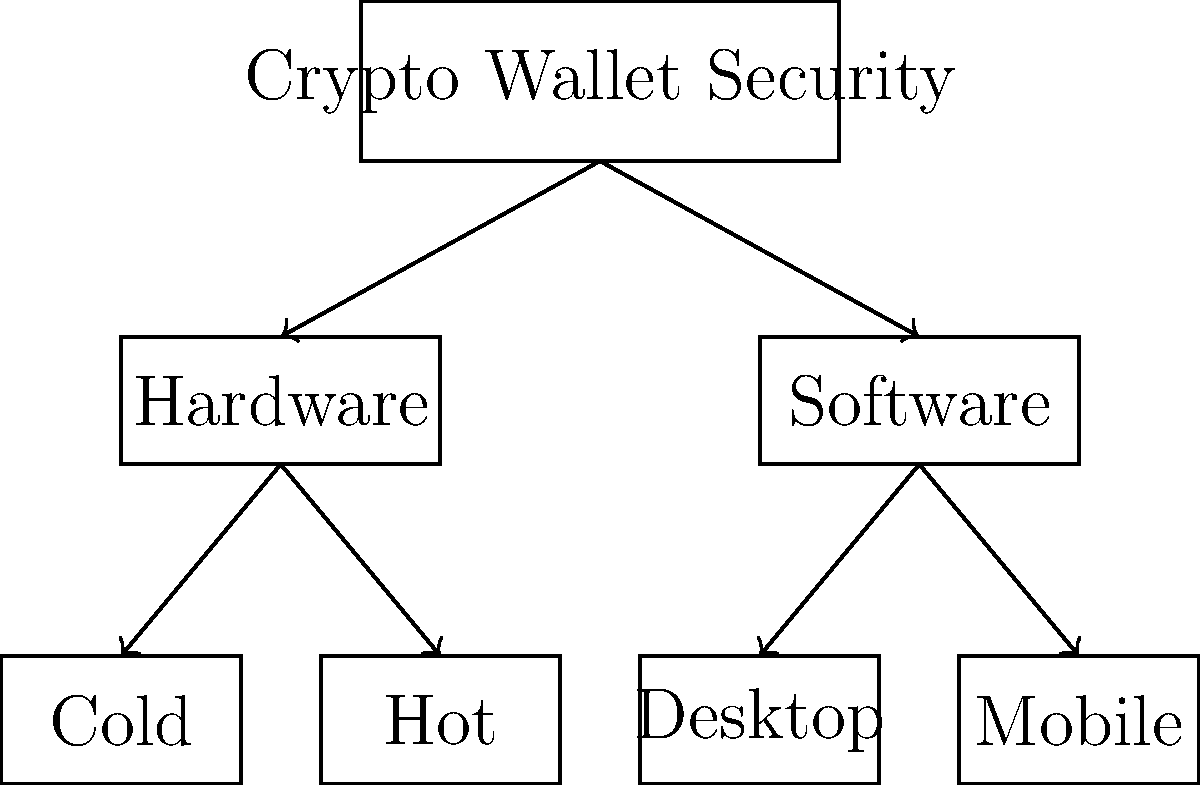Based on the hierarchical diagram of crypto wallet security measures, which type of wallet is generally considered the most secure for long-term storage of large cryptocurrency holdings? To determine the most secure type of wallet for long-term storage of large cryptocurrency holdings, let's analyze the diagram step-by-step:

1. The diagram shows two main categories of crypto wallets: Hardware and Software.

2. Hardware wallets are further divided into:
   a) Cold wallets
   b) Hot wallets

3. Software wallets are divided into:
   a) Desktop wallets
   b) Mobile wallets

4. Cold hardware wallets, also known as cold storage, are considered the most secure option for several reasons:
   - They are offline devices, not connected to the internet, which significantly reduces the risk of hacking or remote attacks.
   - Private keys are stored on the device itself, never leaving it.
   - Transactions must be physically confirmed on the device, adding an extra layer of security.

5. Hot hardware wallets, while still secure, are connected to the internet and thus slightly more vulnerable than cold wallets.

6. Software wallets (both desktop and mobile) are generally considered less secure than hardware wallets because they are more susceptible to malware, hacking, and other online threats.

For long-term storage of large cryptocurrency holdings, security is paramount. Therefore, the cold hardware wallet, being the most secure option, is the best choice for this purpose.
Answer: Cold hardware wallet 